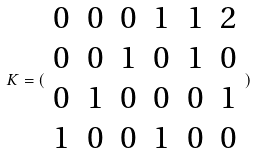<formula> <loc_0><loc_0><loc_500><loc_500>K = ( \begin{array} { c c c c c c } 0 & 0 & 0 & 1 & 1 & 2 \\ 0 & 0 & 1 & 0 & 1 & 0 \\ 0 & 1 & 0 & 0 & 0 & 1 \\ 1 & 0 & 0 & 1 & 0 & 0 \end{array} )</formula> 